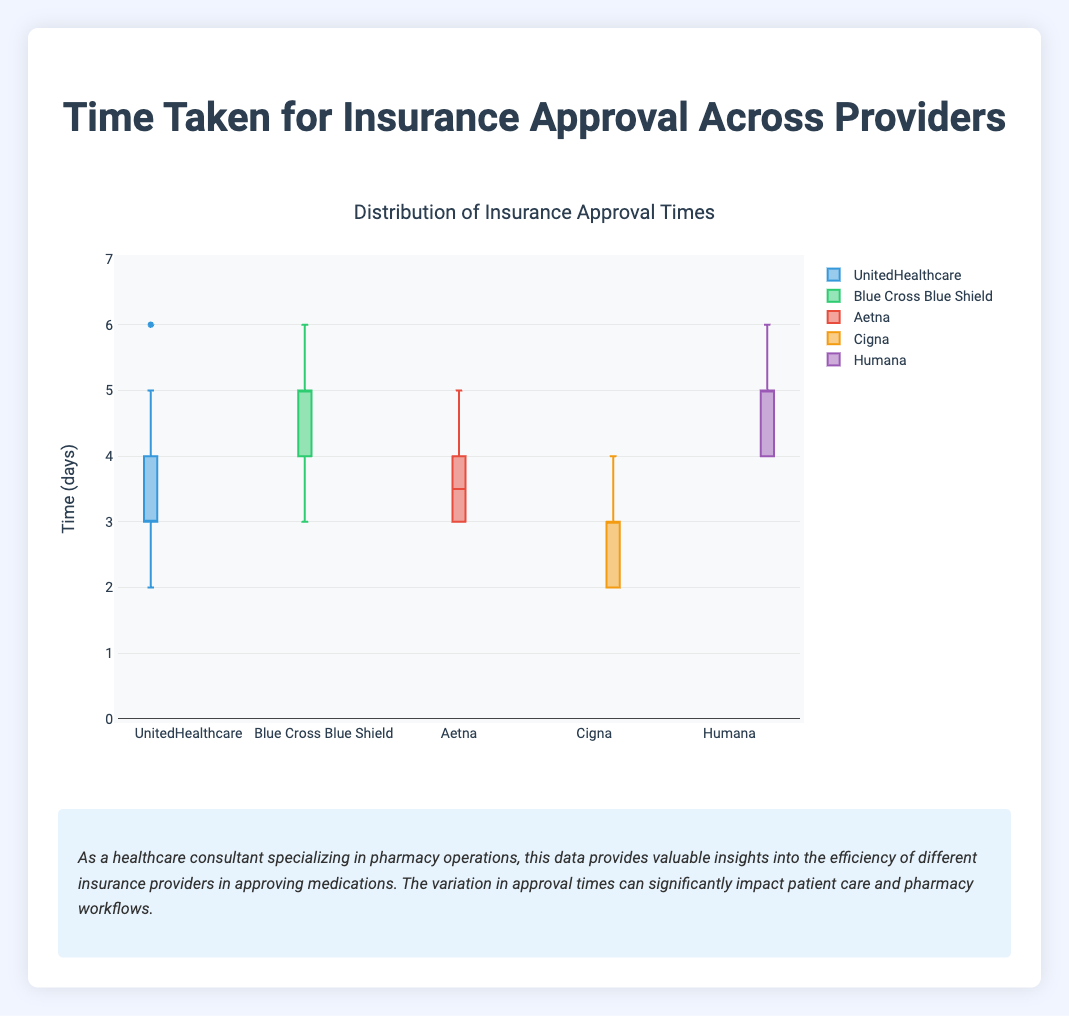What is the title of the box plot? The title can be found at the top of the plot. It reads "Distribution of Insurance Approval Times" explicitly describing what the figure represents.
Answer: Distribution of Insurance Approval Times What is the range of the y-axis? The range of the y-axis is indicated on the axis itself. It starts at 0 and goes up to 7.
Answer: 0 to 7 Which insurance provider has the smallest median approval time? The median is marked by the line inside each box. By comparing the medians of each box plot, we see that Cigna has the lowest median approval time.
Answer: Cigna Which insurance provider has the largest interquartile range (IQR)? The IQR is the range between the first quartile (Q1) and the third quartile (Q3). By comparing the sizes of the boxes, Humana shows the largest IQR.
Answer: Humana What is the median approval time for Blue Cross Blue Shield? The median line inside the Blue Cross Blue Shield box plot shows the median approval time. The median is 5 days.
Answer: 5 days How many outliers are there in the UnitedHealthcare data? Outliers are typically indicated by individual points outside the whiskers. The box plot for UnitedHealthcare does not show any outliers.
Answer: 0 What is the maximum approval time for Cigna? The maximum approval time corresponds to the upper whisker for Cigna. This value is 4 days.
Answer: 4 days Compare the median approval times between Humana and Aetna. Humana's median approval time is 5 days, whereas Aetna's median approval time is 4 days. Thus Humana's median is 1 day greater.
Answer: Humana's median is 1 day greater Which provider has the smallest range of approval times? The range is determined by the difference between the maximum and minimum values (the whiskers). Cigna has the smallest range of 2 days (2 to 4 days).
Answer: Cigna What does the box plot imply about the efficiency of different insurance providers in approving medications? A lower median and smaller IQR imply better efficiency with more consistent approval times. Cigna appears the most efficient with the smallest median and range, while Humana and Blue Cross Blue Shield have higher medians and larger ranges, indicating varied approval times.
Answer: Cigna is the most efficient 